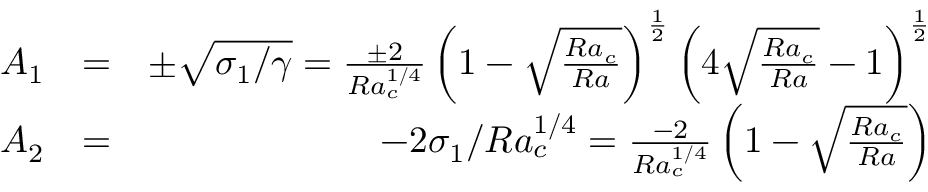Convert formula to latex. <formula><loc_0><loc_0><loc_500><loc_500>\begin{array} { r l r } { A _ { 1 } } & { = } & { \pm \sqrt { \sigma _ { 1 } / \gamma } = \frac { \pm 2 } { R a _ { c } ^ { 1 / 4 } } \left ( 1 - \sqrt { \frac { R a _ { c } } { R a } } \right ) ^ { \frac { 1 } { 2 } } \left ( 4 \sqrt { \frac { R a _ { c } } { R a } } - 1 \right ) ^ { \frac { 1 } { 2 } } } \\ { A _ { 2 } } & { = } & { - 2 \sigma _ { 1 } / R a _ { c } ^ { 1 / 4 } = \frac { - 2 } { R a _ { c } ^ { 1 / 4 } } \left ( 1 - \sqrt { \frac { R a _ { c } } { R a } } \right ) } \end{array}</formula> 